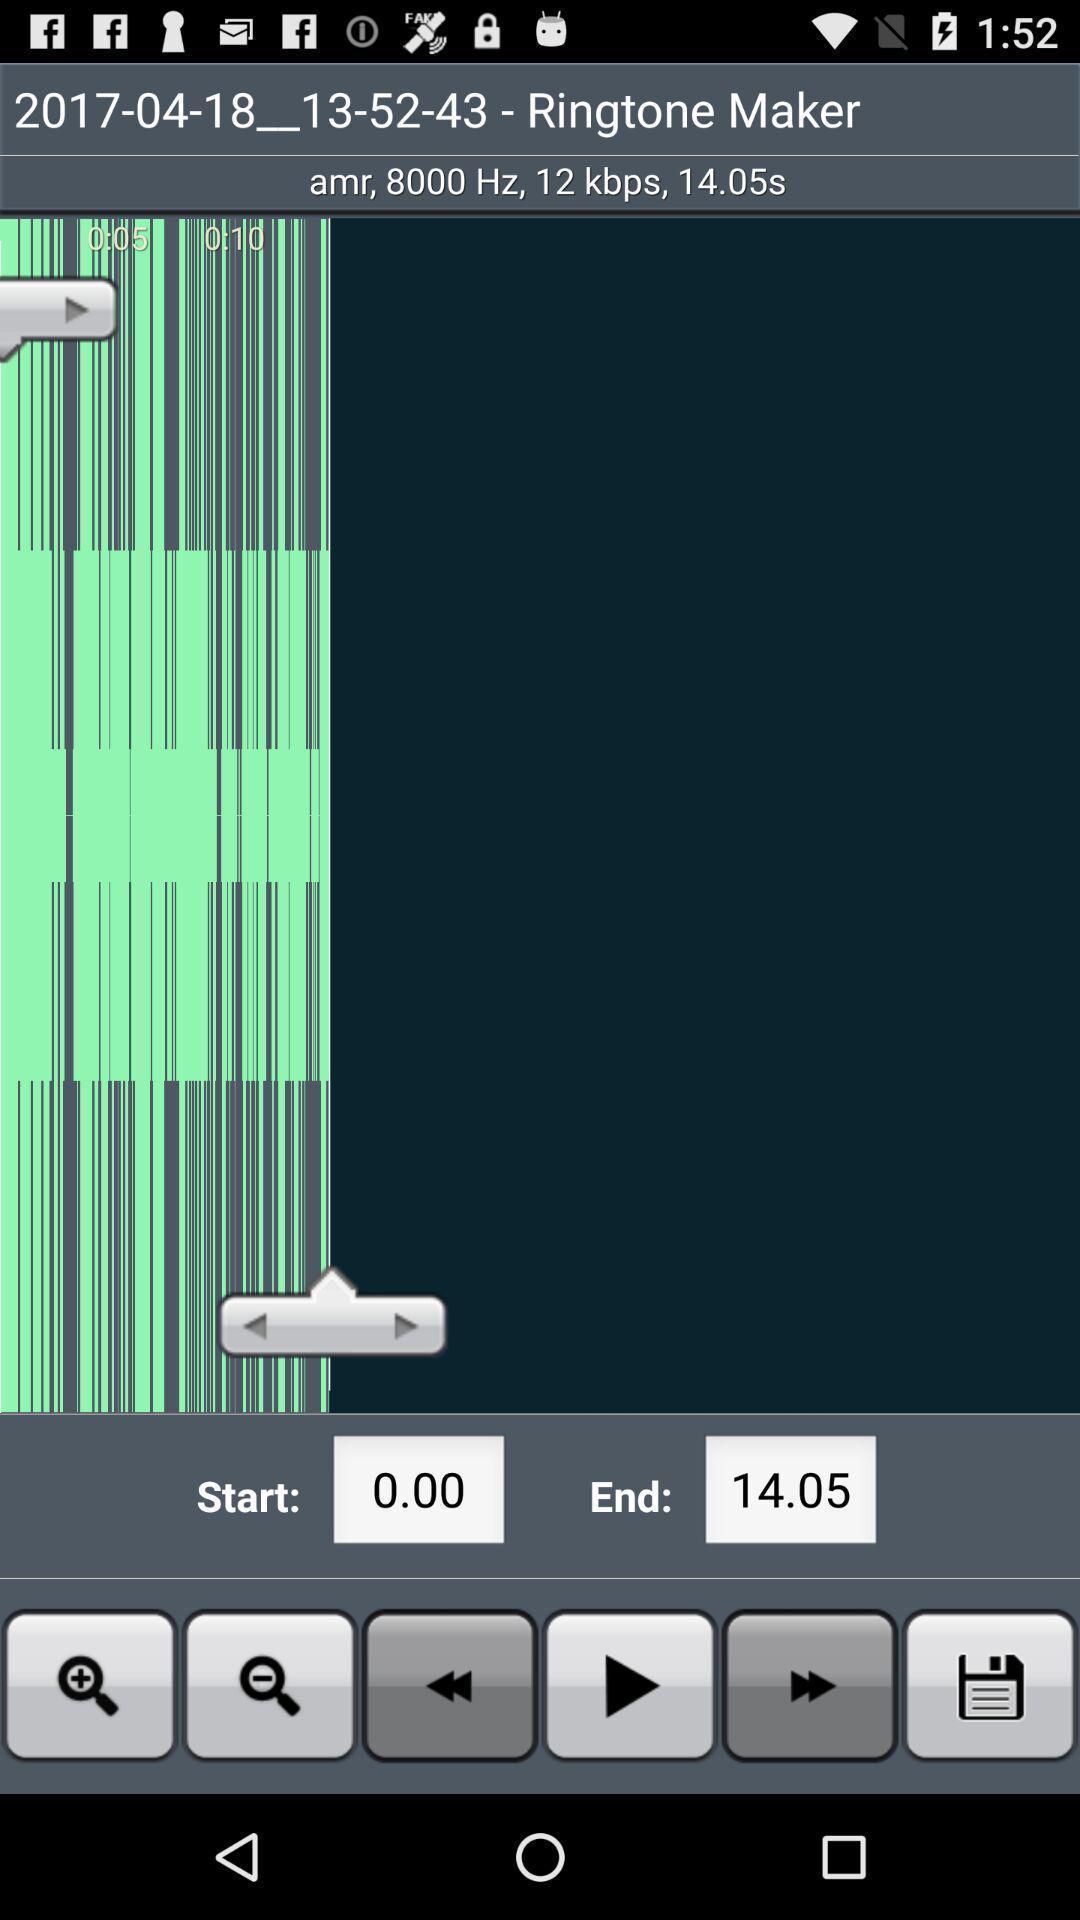Summarize the main components in this picture. Page of an audio editing application. 